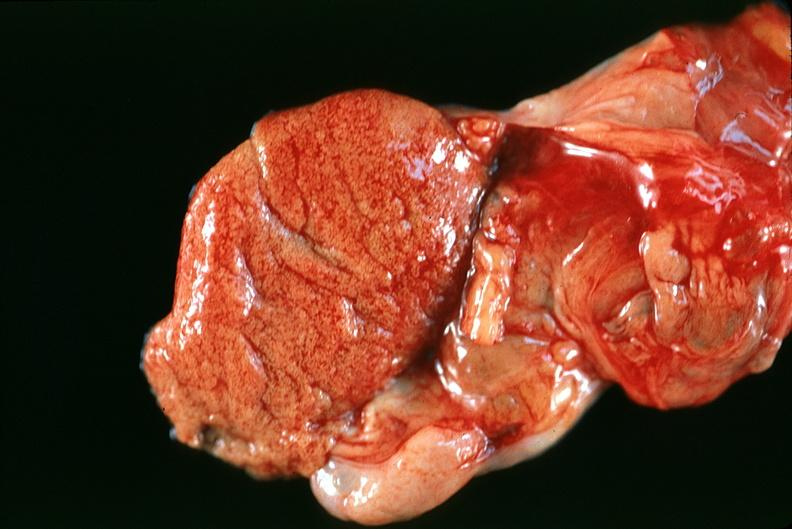does this image show normal testes?
Answer the question using a single word or phrase. Yes 